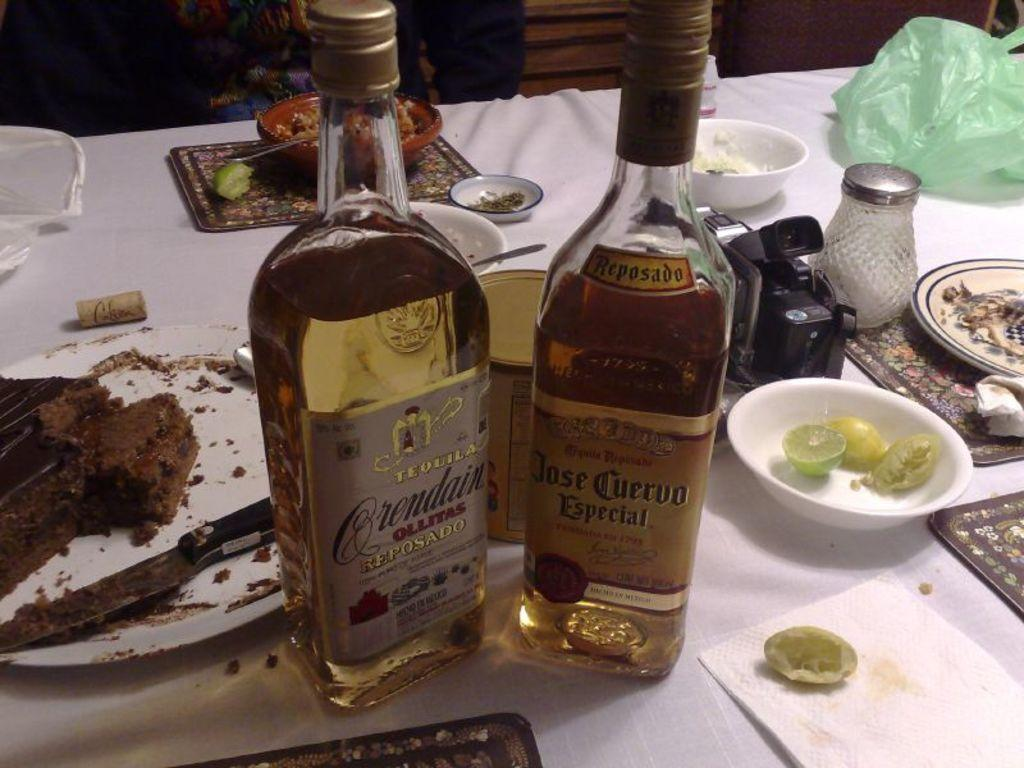<image>
Share a concise interpretation of the image provided. A table of some food and two bottles of liquor one from the brand Jose Cuervo Especial. 